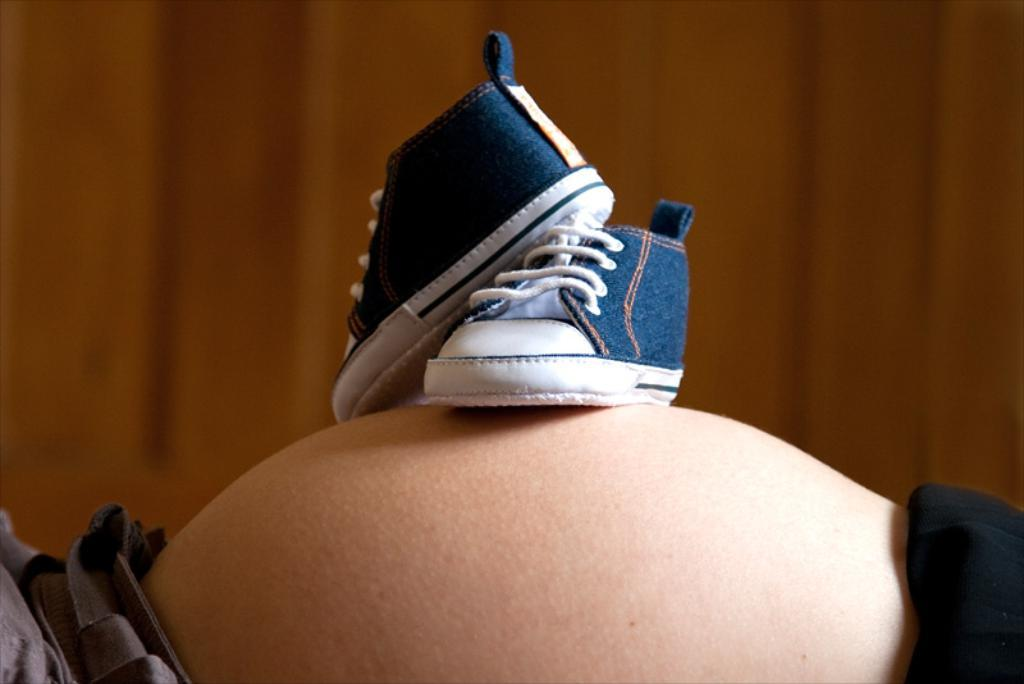What body part is the focus of the image? There is a person's stomach in the image. What is placed on the person's stomach? There are shoes on the person's stomach. What can be seen in the background of the image? There is a wall in the background of the image. How would you describe the clarity of the image? The image appears blurry. How many boats can be seen sailing in the image? There are no boats present in the image. What type of love is being expressed in the image? There is no expression of love in the image; it features a person's stomach with shoes on it. 